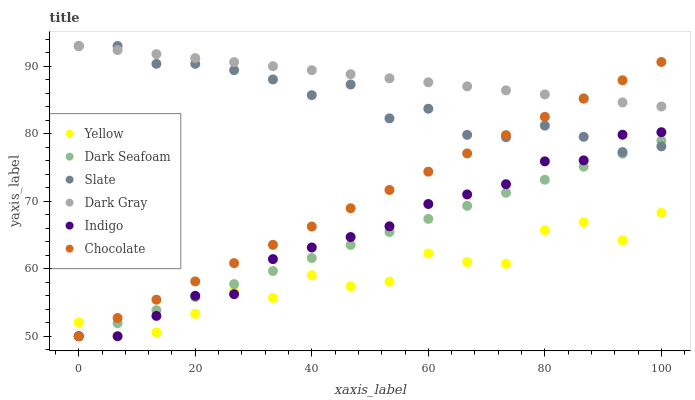Does Yellow have the minimum area under the curve?
Answer yes or no. Yes. Does Dark Gray have the maximum area under the curve?
Answer yes or no. Yes. Does Slate have the minimum area under the curve?
Answer yes or no. No. Does Slate have the maximum area under the curve?
Answer yes or no. No. Is Chocolate the smoothest?
Answer yes or no. Yes. Is Yellow the roughest?
Answer yes or no. Yes. Is Slate the smoothest?
Answer yes or no. No. Is Slate the roughest?
Answer yes or no. No. Does Indigo have the lowest value?
Answer yes or no. Yes. Does Slate have the lowest value?
Answer yes or no. No. Does Dark Gray have the highest value?
Answer yes or no. Yes. Does Yellow have the highest value?
Answer yes or no. No. Is Indigo less than Dark Gray?
Answer yes or no. Yes. Is Dark Gray greater than Indigo?
Answer yes or no. Yes. Does Chocolate intersect Indigo?
Answer yes or no. Yes. Is Chocolate less than Indigo?
Answer yes or no. No. Is Chocolate greater than Indigo?
Answer yes or no. No. Does Indigo intersect Dark Gray?
Answer yes or no. No. 